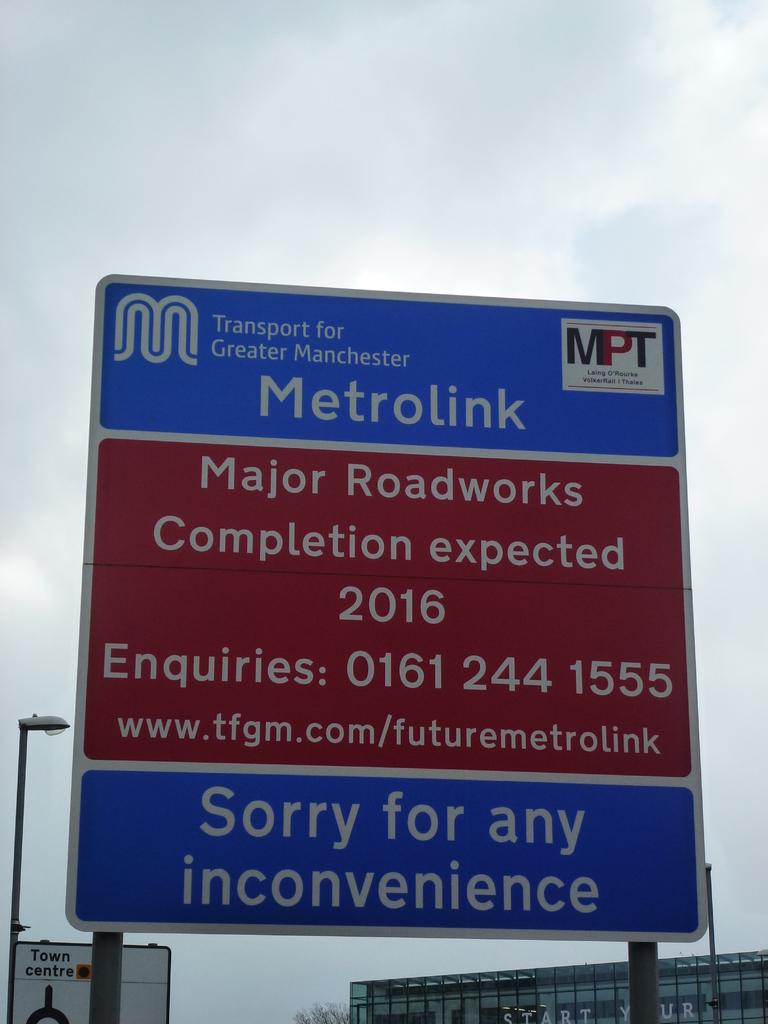<image>
Describe the image concisely. A sign for Metrolinks states major roadworks are happening until 2016. 